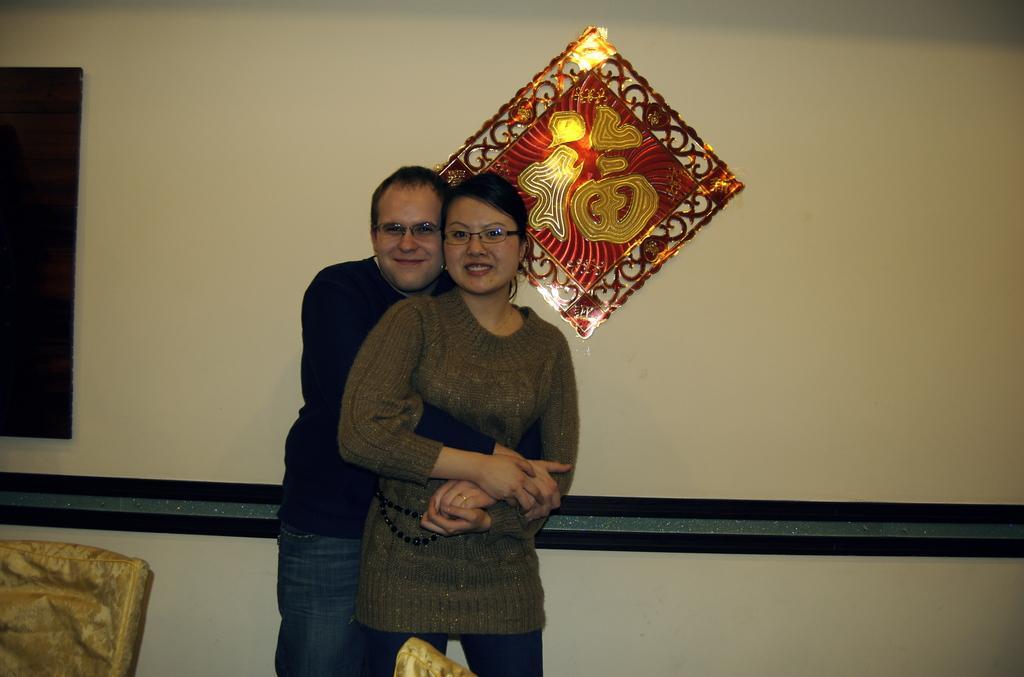Could you give a brief overview of what you see in this image? In this image, there are a few people. In the background, we can see the wall with some objects. We can also see an object on the bottom left corner and an object at the bottom. 